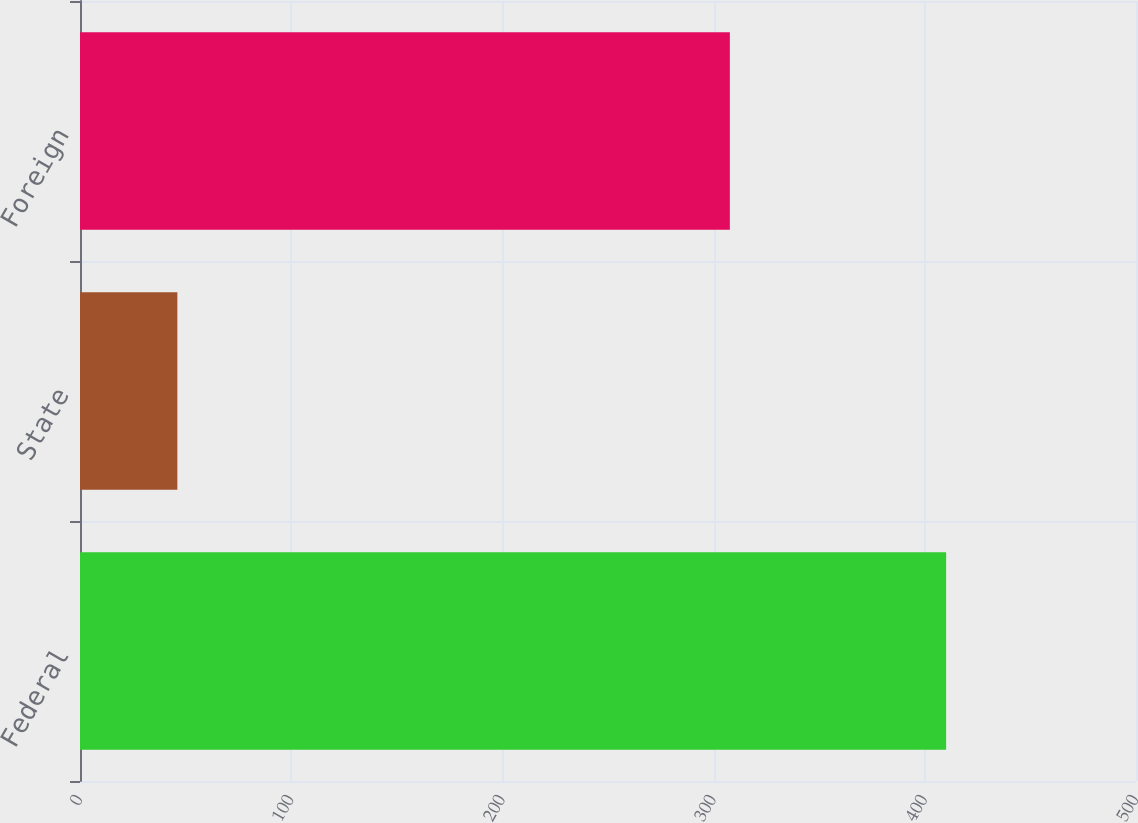Convert chart. <chart><loc_0><loc_0><loc_500><loc_500><bar_chart><fcel>Federal<fcel>State<fcel>Foreign<nl><fcel>410.1<fcel>46.1<fcel>307.7<nl></chart> 